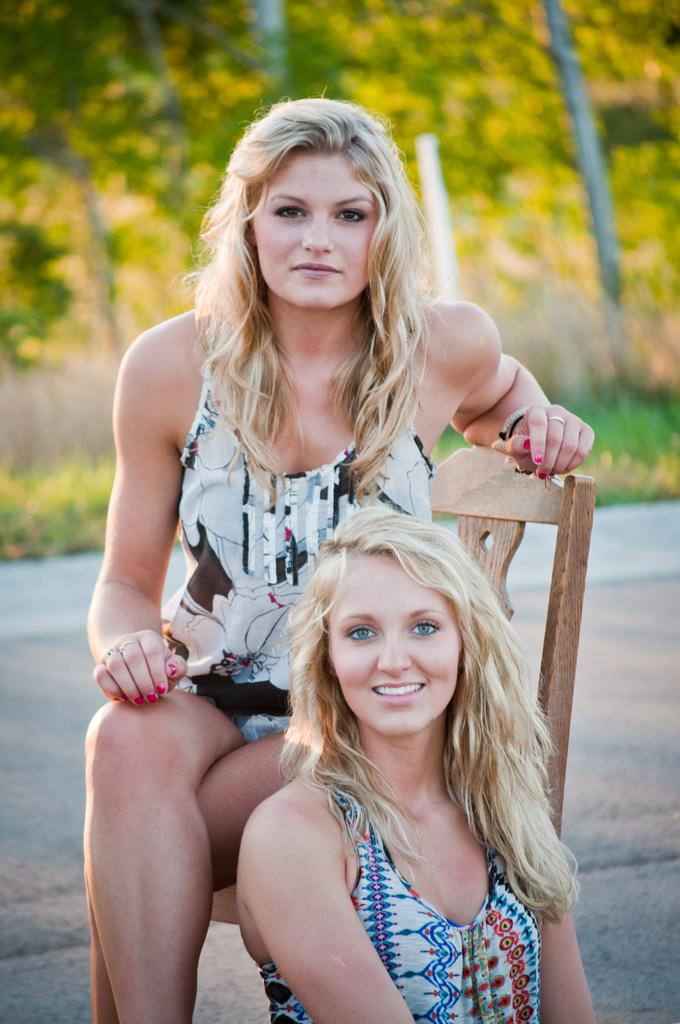What is the main subject of the image? There is a person wearing clothes in the image. What is the person doing in the image? The person is sitting on a chair. Can you describe the other person in the image? There is another person at the bottom of the image. How would you describe the background of the image? The background of the image is blurred. What type of oranges can be seen growing in the wilderness in the image? There are no oranges or wilderness present in the image; it features a person sitting on a chair with another person at the bottom of the image and a blurred background. 